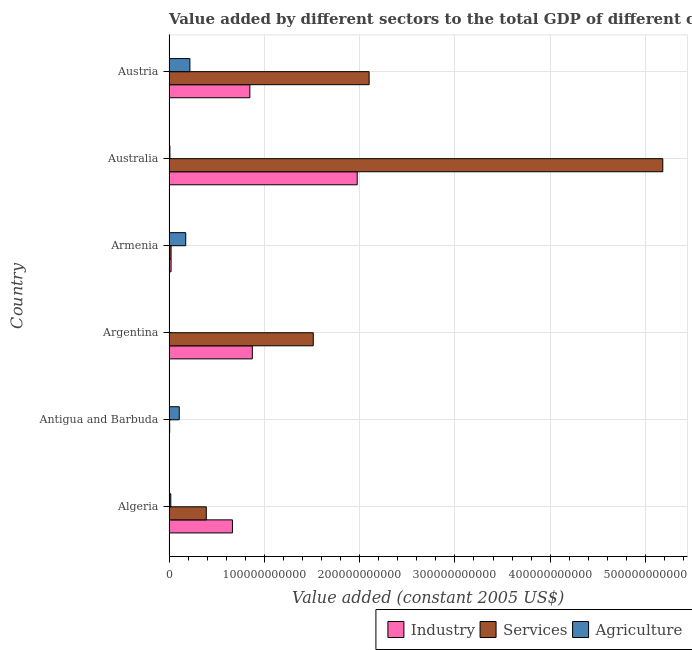Are the number of bars per tick equal to the number of legend labels?
Provide a succinct answer. Yes. What is the label of the 1st group of bars from the top?
Offer a very short reply. Austria. What is the value added by agricultural sector in Austria?
Your answer should be compact. 2.19e+1. Across all countries, what is the maximum value added by industrial sector?
Offer a very short reply. 1.97e+11. Across all countries, what is the minimum value added by industrial sector?
Ensure brevity in your answer.  1.52e+08. In which country was the value added by agricultural sector maximum?
Offer a terse response. Austria. In which country was the value added by services minimum?
Ensure brevity in your answer.  Antigua and Barbuda. What is the total value added by agricultural sector in the graph?
Your answer should be compact. 5.31e+1. What is the difference between the value added by services in Algeria and that in Antigua and Barbuda?
Provide a succinct answer. 3.84e+1. What is the difference between the value added by agricultural sector in Austria and the value added by services in Algeria?
Your response must be concise. -1.72e+1. What is the average value added by services per country?
Keep it short and to the point. 1.54e+11. What is the difference between the value added by industrial sector and value added by agricultural sector in Argentina?
Keep it short and to the point. 8.74e+1. What is the ratio of the value added by industrial sector in Australia to that in Austria?
Give a very brief answer. 2.33. Is the value added by agricultural sector in Antigua and Barbuda less than that in Austria?
Keep it short and to the point. Yes. What is the difference between the highest and the second highest value added by agricultural sector?
Give a very brief answer. 4.37e+09. What is the difference between the highest and the lowest value added by services?
Keep it short and to the point. 5.17e+11. Is the sum of the value added by services in Australia and Austria greater than the maximum value added by agricultural sector across all countries?
Offer a terse response. Yes. What does the 3rd bar from the top in Argentina represents?
Keep it short and to the point. Industry. What does the 1st bar from the bottom in Argentina represents?
Make the answer very short. Industry. Is it the case that in every country, the sum of the value added by industrial sector and value added by services is greater than the value added by agricultural sector?
Your response must be concise. No. How many bars are there?
Give a very brief answer. 18. Are all the bars in the graph horizontal?
Offer a terse response. Yes. What is the difference between two consecutive major ticks on the X-axis?
Give a very brief answer. 1.00e+11. Are the values on the major ticks of X-axis written in scientific E-notation?
Your answer should be compact. No. Does the graph contain any zero values?
Ensure brevity in your answer.  No. How many legend labels are there?
Your response must be concise. 3. How are the legend labels stacked?
Offer a very short reply. Horizontal. What is the title of the graph?
Your answer should be compact. Value added by different sectors to the total GDP of different countries. Does "Agriculture" appear as one of the legend labels in the graph?
Provide a short and direct response. Yes. What is the label or title of the X-axis?
Give a very brief answer. Value added (constant 2005 US$). What is the Value added (constant 2005 US$) of Industry in Algeria?
Your answer should be very brief. 6.66e+1. What is the Value added (constant 2005 US$) in Services in Algeria?
Your response must be concise. 3.91e+1. What is the Value added (constant 2005 US$) in Agriculture in Algeria?
Offer a terse response. 1.89e+09. What is the Value added (constant 2005 US$) in Industry in Antigua and Barbuda?
Keep it short and to the point. 1.52e+08. What is the Value added (constant 2005 US$) in Services in Antigua and Barbuda?
Provide a succinct answer. 7.00e+08. What is the Value added (constant 2005 US$) of Agriculture in Antigua and Barbuda?
Offer a terse response. 1.07e+1. What is the Value added (constant 2005 US$) of Industry in Argentina?
Offer a terse response. 8.74e+1. What is the Value added (constant 2005 US$) of Services in Argentina?
Give a very brief answer. 1.51e+11. What is the Value added (constant 2005 US$) in Agriculture in Argentina?
Offer a terse response. 1.53e+07. What is the Value added (constant 2005 US$) of Industry in Armenia?
Provide a short and direct response. 2.17e+09. What is the Value added (constant 2005 US$) in Services in Armenia?
Give a very brief answer. 2.16e+09. What is the Value added (constant 2005 US$) of Agriculture in Armenia?
Provide a succinct answer. 1.76e+1. What is the Value added (constant 2005 US$) in Industry in Australia?
Keep it short and to the point. 1.97e+11. What is the Value added (constant 2005 US$) of Services in Australia?
Your response must be concise. 5.18e+11. What is the Value added (constant 2005 US$) in Agriculture in Australia?
Offer a very short reply. 9.52e+08. What is the Value added (constant 2005 US$) in Industry in Austria?
Your answer should be compact. 8.48e+1. What is the Value added (constant 2005 US$) in Services in Austria?
Offer a very short reply. 2.10e+11. What is the Value added (constant 2005 US$) of Agriculture in Austria?
Make the answer very short. 2.19e+1. Across all countries, what is the maximum Value added (constant 2005 US$) of Industry?
Make the answer very short. 1.97e+11. Across all countries, what is the maximum Value added (constant 2005 US$) in Services?
Make the answer very short. 5.18e+11. Across all countries, what is the maximum Value added (constant 2005 US$) in Agriculture?
Ensure brevity in your answer.  2.19e+1. Across all countries, what is the minimum Value added (constant 2005 US$) in Industry?
Ensure brevity in your answer.  1.52e+08. Across all countries, what is the minimum Value added (constant 2005 US$) in Services?
Your response must be concise. 7.00e+08. Across all countries, what is the minimum Value added (constant 2005 US$) of Agriculture?
Provide a short and direct response. 1.53e+07. What is the total Value added (constant 2005 US$) of Industry in the graph?
Your response must be concise. 4.39e+11. What is the total Value added (constant 2005 US$) in Services in the graph?
Provide a succinct answer. 9.21e+11. What is the total Value added (constant 2005 US$) in Agriculture in the graph?
Your answer should be very brief. 5.31e+1. What is the difference between the Value added (constant 2005 US$) of Industry in Algeria and that in Antigua and Barbuda?
Make the answer very short. 6.64e+1. What is the difference between the Value added (constant 2005 US$) of Services in Algeria and that in Antigua and Barbuda?
Provide a succinct answer. 3.84e+1. What is the difference between the Value added (constant 2005 US$) of Agriculture in Algeria and that in Antigua and Barbuda?
Ensure brevity in your answer.  -8.86e+09. What is the difference between the Value added (constant 2005 US$) of Industry in Algeria and that in Argentina?
Offer a very short reply. -2.08e+1. What is the difference between the Value added (constant 2005 US$) in Services in Algeria and that in Argentina?
Your answer should be compact. -1.12e+11. What is the difference between the Value added (constant 2005 US$) in Agriculture in Algeria and that in Argentina?
Offer a very short reply. 1.87e+09. What is the difference between the Value added (constant 2005 US$) in Industry in Algeria and that in Armenia?
Ensure brevity in your answer.  6.44e+1. What is the difference between the Value added (constant 2005 US$) of Services in Algeria and that in Armenia?
Offer a terse response. 3.70e+1. What is the difference between the Value added (constant 2005 US$) in Agriculture in Algeria and that in Armenia?
Offer a terse response. -1.57e+1. What is the difference between the Value added (constant 2005 US$) in Industry in Algeria and that in Australia?
Keep it short and to the point. -1.31e+11. What is the difference between the Value added (constant 2005 US$) in Services in Algeria and that in Australia?
Make the answer very short. -4.79e+11. What is the difference between the Value added (constant 2005 US$) in Agriculture in Algeria and that in Australia?
Make the answer very short. 9.36e+08. What is the difference between the Value added (constant 2005 US$) in Industry in Algeria and that in Austria?
Offer a terse response. -1.83e+1. What is the difference between the Value added (constant 2005 US$) in Services in Algeria and that in Austria?
Keep it short and to the point. -1.71e+11. What is the difference between the Value added (constant 2005 US$) of Agriculture in Algeria and that in Austria?
Keep it short and to the point. -2.00e+1. What is the difference between the Value added (constant 2005 US$) of Industry in Antigua and Barbuda and that in Argentina?
Give a very brief answer. -8.73e+1. What is the difference between the Value added (constant 2005 US$) in Services in Antigua and Barbuda and that in Argentina?
Your answer should be compact. -1.51e+11. What is the difference between the Value added (constant 2005 US$) of Agriculture in Antigua and Barbuda and that in Argentina?
Offer a very short reply. 1.07e+1. What is the difference between the Value added (constant 2005 US$) in Industry in Antigua and Barbuda and that in Armenia?
Your response must be concise. -2.02e+09. What is the difference between the Value added (constant 2005 US$) in Services in Antigua and Barbuda and that in Armenia?
Give a very brief answer. -1.46e+09. What is the difference between the Value added (constant 2005 US$) of Agriculture in Antigua and Barbuda and that in Armenia?
Offer a very short reply. -6.81e+09. What is the difference between the Value added (constant 2005 US$) of Industry in Antigua and Barbuda and that in Australia?
Your answer should be compact. -1.97e+11. What is the difference between the Value added (constant 2005 US$) in Services in Antigua and Barbuda and that in Australia?
Your answer should be compact. -5.17e+11. What is the difference between the Value added (constant 2005 US$) of Agriculture in Antigua and Barbuda and that in Australia?
Your response must be concise. 9.80e+09. What is the difference between the Value added (constant 2005 US$) in Industry in Antigua and Barbuda and that in Austria?
Provide a short and direct response. -8.47e+1. What is the difference between the Value added (constant 2005 US$) of Services in Antigua and Barbuda and that in Austria?
Give a very brief answer. -2.09e+11. What is the difference between the Value added (constant 2005 US$) of Agriculture in Antigua and Barbuda and that in Austria?
Offer a terse response. -1.12e+1. What is the difference between the Value added (constant 2005 US$) of Industry in Argentina and that in Armenia?
Provide a short and direct response. 8.52e+1. What is the difference between the Value added (constant 2005 US$) of Services in Argentina and that in Armenia?
Provide a short and direct response. 1.49e+11. What is the difference between the Value added (constant 2005 US$) in Agriculture in Argentina and that in Armenia?
Your response must be concise. -1.75e+1. What is the difference between the Value added (constant 2005 US$) in Industry in Argentina and that in Australia?
Your answer should be compact. -1.10e+11. What is the difference between the Value added (constant 2005 US$) of Services in Argentina and that in Australia?
Make the answer very short. -3.67e+11. What is the difference between the Value added (constant 2005 US$) of Agriculture in Argentina and that in Australia?
Your answer should be compact. -9.36e+08. What is the difference between the Value added (constant 2005 US$) of Industry in Argentina and that in Austria?
Offer a very short reply. 2.59e+09. What is the difference between the Value added (constant 2005 US$) in Services in Argentina and that in Austria?
Offer a very short reply. -5.86e+1. What is the difference between the Value added (constant 2005 US$) of Agriculture in Argentina and that in Austria?
Ensure brevity in your answer.  -2.19e+1. What is the difference between the Value added (constant 2005 US$) in Industry in Armenia and that in Australia?
Make the answer very short. -1.95e+11. What is the difference between the Value added (constant 2005 US$) in Services in Armenia and that in Australia?
Your answer should be very brief. -5.16e+11. What is the difference between the Value added (constant 2005 US$) in Agriculture in Armenia and that in Australia?
Ensure brevity in your answer.  1.66e+1. What is the difference between the Value added (constant 2005 US$) of Industry in Armenia and that in Austria?
Provide a succinct answer. -8.27e+1. What is the difference between the Value added (constant 2005 US$) of Services in Armenia and that in Austria?
Provide a short and direct response. -2.08e+11. What is the difference between the Value added (constant 2005 US$) of Agriculture in Armenia and that in Austria?
Provide a succinct answer. -4.37e+09. What is the difference between the Value added (constant 2005 US$) in Industry in Australia and that in Austria?
Give a very brief answer. 1.13e+11. What is the difference between the Value added (constant 2005 US$) in Services in Australia and that in Austria?
Provide a short and direct response. 3.08e+11. What is the difference between the Value added (constant 2005 US$) in Agriculture in Australia and that in Austria?
Provide a succinct answer. -2.10e+1. What is the difference between the Value added (constant 2005 US$) of Industry in Algeria and the Value added (constant 2005 US$) of Services in Antigua and Barbuda?
Provide a short and direct response. 6.59e+1. What is the difference between the Value added (constant 2005 US$) of Industry in Algeria and the Value added (constant 2005 US$) of Agriculture in Antigua and Barbuda?
Your response must be concise. 5.58e+1. What is the difference between the Value added (constant 2005 US$) in Services in Algeria and the Value added (constant 2005 US$) in Agriculture in Antigua and Barbuda?
Make the answer very short. 2.84e+1. What is the difference between the Value added (constant 2005 US$) of Industry in Algeria and the Value added (constant 2005 US$) of Services in Argentina?
Ensure brevity in your answer.  -8.48e+1. What is the difference between the Value added (constant 2005 US$) of Industry in Algeria and the Value added (constant 2005 US$) of Agriculture in Argentina?
Give a very brief answer. 6.65e+1. What is the difference between the Value added (constant 2005 US$) of Services in Algeria and the Value added (constant 2005 US$) of Agriculture in Argentina?
Your response must be concise. 3.91e+1. What is the difference between the Value added (constant 2005 US$) in Industry in Algeria and the Value added (constant 2005 US$) in Services in Armenia?
Keep it short and to the point. 6.44e+1. What is the difference between the Value added (constant 2005 US$) in Industry in Algeria and the Value added (constant 2005 US$) in Agriculture in Armenia?
Offer a terse response. 4.90e+1. What is the difference between the Value added (constant 2005 US$) of Services in Algeria and the Value added (constant 2005 US$) of Agriculture in Armenia?
Give a very brief answer. 2.16e+1. What is the difference between the Value added (constant 2005 US$) in Industry in Algeria and the Value added (constant 2005 US$) in Services in Australia?
Keep it short and to the point. -4.52e+11. What is the difference between the Value added (constant 2005 US$) of Industry in Algeria and the Value added (constant 2005 US$) of Agriculture in Australia?
Offer a terse response. 6.56e+1. What is the difference between the Value added (constant 2005 US$) in Services in Algeria and the Value added (constant 2005 US$) in Agriculture in Australia?
Your answer should be compact. 3.82e+1. What is the difference between the Value added (constant 2005 US$) in Industry in Algeria and the Value added (constant 2005 US$) in Services in Austria?
Your answer should be very brief. -1.43e+11. What is the difference between the Value added (constant 2005 US$) in Industry in Algeria and the Value added (constant 2005 US$) in Agriculture in Austria?
Your answer should be very brief. 4.46e+1. What is the difference between the Value added (constant 2005 US$) in Services in Algeria and the Value added (constant 2005 US$) in Agriculture in Austria?
Your answer should be very brief. 1.72e+1. What is the difference between the Value added (constant 2005 US$) in Industry in Antigua and Barbuda and the Value added (constant 2005 US$) in Services in Argentina?
Make the answer very short. -1.51e+11. What is the difference between the Value added (constant 2005 US$) in Industry in Antigua and Barbuda and the Value added (constant 2005 US$) in Agriculture in Argentina?
Ensure brevity in your answer.  1.37e+08. What is the difference between the Value added (constant 2005 US$) in Services in Antigua and Barbuda and the Value added (constant 2005 US$) in Agriculture in Argentina?
Your answer should be compact. 6.85e+08. What is the difference between the Value added (constant 2005 US$) in Industry in Antigua and Barbuda and the Value added (constant 2005 US$) in Services in Armenia?
Your answer should be compact. -2.01e+09. What is the difference between the Value added (constant 2005 US$) in Industry in Antigua and Barbuda and the Value added (constant 2005 US$) in Agriculture in Armenia?
Offer a very short reply. -1.74e+1. What is the difference between the Value added (constant 2005 US$) of Services in Antigua and Barbuda and the Value added (constant 2005 US$) of Agriculture in Armenia?
Your response must be concise. -1.69e+1. What is the difference between the Value added (constant 2005 US$) of Industry in Antigua and Barbuda and the Value added (constant 2005 US$) of Services in Australia?
Your response must be concise. -5.18e+11. What is the difference between the Value added (constant 2005 US$) of Industry in Antigua and Barbuda and the Value added (constant 2005 US$) of Agriculture in Australia?
Keep it short and to the point. -8.00e+08. What is the difference between the Value added (constant 2005 US$) in Services in Antigua and Barbuda and the Value added (constant 2005 US$) in Agriculture in Australia?
Give a very brief answer. -2.51e+08. What is the difference between the Value added (constant 2005 US$) in Industry in Antigua and Barbuda and the Value added (constant 2005 US$) in Services in Austria?
Keep it short and to the point. -2.10e+11. What is the difference between the Value added (constant 2005 US$) in Industry in Antigua and Barbuda and the Value added (constant 2005 US$) in Agriculture in Austria?
Give a very brief answer. -2.18e+1. What is the difference between the Value added (constant 2005 US$) in Services in Antigua and Barbuda and the Value added (constant 2005 US$) in Agriculture in Austria?
Ensure brevity in your answer.  -2.12e+1. What is the difference between the Value added (constant 2005 US$) of Industry in Argentina and the Value added (constant 2005 US$) of Services in Armenia?
Keep it short and to the point. 8.52e+1. What is the difference between the Value added (constant 2005 US$) of Industry in Argentina and the Value added (constant 2005 US$) of Agriculture in Armenia?
Offer a very short reply. 6.99e+1. What is the difference between the Value added (constant 2005 US$) of Services in Argentina and the Value added (constant 2005 US$) of Agriculture in Armenia?
Offer a very short reply. 1.34e+11. What is the difference between the Value added (constant 2005 US$) in Industry in Argentina and the Value added (constant 2005 US$) in Services in Australia?
Offer a terse response. -4.31e+11. What is the difference between the Value added (constant 2005 US$) of Industry in Argentina and the Value added (constant 2005 US$) of Agriculture in Australia?
Your response must be concise. 8.65e+1. What is the difference between the Value added (constant 2005 US$) of Services in Argentina and the Value added (constant 2005 US$) of Agriculture in Australia?
Your answer should be compact. 1.50e+11. What is the difference between the Value added (constant 2005 US$) of Industry in Argentina and the Value added (constant 2005 US$) of Services in Austria?
Give a very brief answer. -1.23e+11. What is the difference between the Value added (constant 2005 US$) of Industry in Argentina and the Value added (constant 2005 US$) of Agriculture in Austria?
Make the answer very short. 6.55e+1. What is the difference between the Value added (constant 2005 US$) of Services in Argentina and the Value added (constant 2005 US$) of Agriculture in Austria?
Provide a short and direct response. 1.29e+11. What is the difference between the Value added (constant 2005 US$) in Industry in Armenia and the Value added (constant 2005 US$) in Services in Australia?
Provide a succinct answer. -5.16e+11. What is the difference between the Value added (constant 2005 US$) of Industry in Armenia and the Value added (constant 2005 US$) of Agriculture in Australia?
Ensure brevity in your answer.  1.22e+09. What is the difference between the Value added (constant 2005 US$) in Services in Armenia and the Value added (constant 2005 US$) in Agriculture in Australia?
Offer a very short reply. 1.21e+09. What is the difference between the Value added (constant 2005 US$) of Industry in Armenia and the Value added (constant 2005 US$) of Services in Austria?
Give a very brief answer. -2.08e+11. What is the difference between the Value added (constant 2005 US$) of Industry in Armenia and the Value added (constant 2005 US$) of Agriculture in Austria?
Ensure brevity in your answer.  -1.98e+1. What is the difference between the Value added (constant 2005 US$) of Services in Armenia and the Value added (constant 2005 US$) of Agriculture in Austria?
Make the answer very short. -1.98e+1. What is the difference between the Value added (constant 2005 US$) of Industry in Australia and the Value added (constant 2005 US$) of Services in Austria?
Provide a succinct answer. -1.25e+1. What is the difference between the Value added (constant 2005 US$) of Industry in Australia and the Value added (constant 2005 US$) of Agriculture in Austria?
Ensure brevity in your answer.  1.76e+11. What is the difference between the Value added (constant 2005 US$) of Services in Australia and the Value added (constant 2005 US$) of Agriculture in Austria?
Keep it short and to the point. 4.96e+11. What is the average Value added (constant 2005 US$) of Industry per country?
Offer a terse response. 7.31e+1. What is the average Value added (constant 2005 US$) of Services per country?
Your response must be concise. 1.54e+11. What is the average Value added (constant 2005 US$) of Agriculture per country?
Your response must be concise. 8.85e+09. What is the difference between the Value added (constant 2005 US$) in Industry and Value added (constant 2005 US$) in Services in Algeria?
Make the answer very short. 2.74e+1. What is the difference between the Value added (constant 2005 US$) of Industry and Value added (constant 2005 US$) of Agriculture in Algeria?
Offer a terse response. 6.47e+1. What is the difference between the Value added (constant 2005 US$) in Services and Value added (constant 2005 US$) in Agriculture in Algeria?
Your answer should be compact. 3.72e+1. What is the difference between the Value added (constant 2005 US$) of Industry and Value added (constant 2005 US$) of Services in Antigua and Barbuda?
Provide a short and direct response. -5.48e+08. What is the difference between the Value added (constant 2005 US$) of Industry and Value added (constant 2005 US$) of Agriculture in Antigua and Barbuda?
Make the answer very short. -1.06e+1. What is the difference between the Value added (constant 2005 US$) in Services and Value added (constant 2005 US$) in Agriculture in Antigua and Barbuda?
Keep it short and to the point. -1.00e+1. What is the difference between the Value added (constant 2005 US$) in Industry and Value added (constant 2005 US$) in Services in Argentina?
Make the answer very short. -6.40e+1. What is the difference between the Value added (constant 2005 US$) in Industry and Value added (constant 2005 US$) in Agriculture in Argentina?
Provide a succinct answer. 8.74e+1. What is the difference between the Value added (constant 2005 US$) in Services and Value added (constant 2005 US$) in Agriculture in Argentina?
Your answer should be very brief. 1.51e+11. What is the difference between the Value added (constant 2005 US$) in Industry and Value added (constant 2005 US$) in Services in Armenia?
Give a very brief answer. 5.08e+06. What is the difference between the Value added (constant 2005 US$) in Industry and Value added (constant 2005 US$) in Agriculture in Armenia?
Give a very brief answer. -1.54e+1. What is the difference between the Value added (constant 2005 US$) of Services and Value added (constant 2005 US$) of Agriculture in Armenia?
Offer a very short reply. -1.54e+1. What is the difference between the Value added (constant 2005 US$) in Industry and Value added (constant 2005 US$) in Services in Australia?
Offer a terse response. -3.21e+11. What is the difference between the Value added (constant 2005 US$) of Industry and Value added (constant 2005 US$) of Agriculture in Australia?
Give a very brief answer. 1.97e+11. What is the difference between the Value added (constant 2005 US$) in Services and Value added (constant 2005 US$) in Agriculture in Australia?
Keep it short and to the point. 5.17e+11. What is the difference between the Value added (constant 2005 US$) in Industry and Value added (constant 2005 US$) in Services in Austria?
Offer a very short reply. -1.25e+11. What is the difference between the Value added (constant 2005 US$) of Industry and Value added (constant 2005 US$) of Agriculture in Austria?
Give a very brief answer. 6.29e+1. What is the difference between the Value added (constant 2005 US$) in Services and Value added (constant 2005 US$) in Agriculture in Austria?
Make the answer very short. 1.88e+11. What is the ratio of the Value added (constant 2005 US$) in Industry in Algeria to that in Antigua and Barbuda?
Offer a very short reply. 438.16. What is the ratio of the Value added (constant 2005 US$) of Services in Algeria to that in Antigua and Barbuda?
Offer a very short reply. 55.88. What is the ratio of the Value added (constant 2005 US$) in Agriculture in Algeria to that in Antigua and Barbuda?
Give a very brief answer. 0.18. What is the ratio of the Value added (constant 2005 US$) of Industry in Algeria to that in Argentina?
Give a very brief answer. 0.76. What is the ratio of the Value added (constant 2005 US$) in Services in Algeria to that in Argentina?
Give a very brief answer. 0.26. What is the ratio of the Value added (constant 2005 US$) in Agriculture in Algeria to that in Argentina?
Your answer should be compact. 123.27. What is the ratio of the Value added (constant 2005 US$) of Industry in Algeria to that in Armenia?
Keep it short and to the point. 30.68. What is the ratio of the Value added (constant 2005 US$) of Services in Algeria to that in Armenia?
Offer a very short reply. 18.07. What is the ratio of the Value added (constant 2005 US$) in Agriculture in Algeria to that in Armenia?
Ensure brevity in your answer.  0.11. What is the ratio of the Value added (constant 2005 US$) in Industry in Algeria to that in Australia?
Your answer should be very brief. 0.34. What is the ratio of the Value added (constant 2005 US$) in Services in Algeria to that in Australia?
Offer a very short reply. 0.08. What is the ratio of the Value added (constant 2005 US$) in Agriculture in Algeria to that in Australia?
Offer a very short reply. 1.98. What is the ratio of the Value added (constant 2005 US$) of Industry in Algeria to that in Austria?
Give a very brief answer. 0.78. What is the ratio of the Value added (constant 2005 US$) in Services in Algeria to that in Austria?
Keep it short and to the point. 0.19. What is the ratio of the Value added (constant 2005 US$) in Agriculture in Algeria to that in Austria?
Give a very brief answer. 0.09. What is the ratio of the Value added (constant 2005 US$) in Industry in Antigua and Barbuda to that in Argentina?
Provide a succinct answer. 0. What is the ratio of the Value added (constant 2005 US$) of Services in Antigua and Barbuda to that in Argentina?
Offer a terse response. 0. What is the ratio of the Value added (constant 2005 US$) in Agriculture in Antigua and Barbuda to that in Argentina?
Your answer should be very brief. 701.84. What is the ratio of the Value added (constant 2005 US$) in Industry in Antigua and Barbuda to that in Armenia?
Your answer should be compact. 0.07. What is the ratio of the Value added (constant 2005 US$) of Services in Antigua and Barbuda to that in Armenia?
Ensure brevity in your answer.  0.32. What is the ratio of the Value added (constant 2005 US$) of Agriculture in Antigua and Barbuda to that in Armenia?
Give a very brief answer. 0.61. What is the ratio of the Value added (constant 2005 US$) in Industry in Antigua and Barbuda to that in Australia?
Your answer should be very brief. 0. What is the ratio of the Value added (constant 2005 US$) in Services in Antigua and Barbuda to that in Australia?
Make the answer very short. 0. What is the ratio of the Value added (constant 2005 US$) in Agriculture in Antigua and Barbuda to that in Australia?
Your answer should be very brief. 11.29. What is the ratio of the Value added (constant 2005 US$) of Industry in Antigua and Barbuda to that in Austria?
Offer a very short reply. 0. What is the ratio of the Value added (constant 2005 US$) in Services in Antigua and Barbuda to that in Austria?
Your answer should be compact. 0. What is the ratio of the Value added (constant 2005 US$) in Agriculture in Antigua and Barbuda to that in Austria?
Ensure brevity in your answer.  0.49. What is the ratio of the Value added (constant 2005 US$) of Industry in Argentina to that in Armenia?
Your answer should be compact. 40.29. What is the ratio of the Value added (constant 2005 US$) of Services in Argentina to that in Armenia?
Keep it short and to the point. 69.93. What is the ratio of the Value added (constant 2005 US$) in Agriculture in Argentina to that in Armenia?
Your answer should be very brief. 0. What is the ratio of the Value added (constant 2005 US$) in Industry in Argentina to that in Australia?
Give a very brief answer. 0.44. What is the ratio of the Value added (constant 2005 US$) in Services in Argentina to that in Australia?
Provide a succinct answer. 0.29. What is the ratio of the Value added (constant 2005 US$) in Agriculture in Argentina to that in Australia?
Provide a succinct answer. 0.02. What is the ratio of the Value added (constant 2005 US$) in Industry in Argentina to that in Austria?
Your answer should be very brief. 1.03. What is the ratio of the Value added (constant 2005 US$) of Services in Argentina to that in Austria?
Your answer should be compact. 0.72. What is the ratio of the Value added (constant 2005 US$) in Agriculture in Argentina to that in Austria?
Make the answer very short. 0. What is the ratio of the Value added (constant 2005 US$) in Industry in Armenia to that in Australia?
Make the answer very short. 0.01. What is the ratio of the Value added (constant 2005 US$) of Services in Armenia to that in Australia?
Provide a succinct answer. 0. What is the ratio of the Value added (constant 2005 US$) in Agriculture in Armenia to that in Australia?
Offer a terse response. 18.45. What is the ratio of the Value added (constant 2005 US$) in Industry in Armenia to that in Austria?
Provide a succinct answer. 0.03. What is the ratio of the Value added (constant 2005 US$) of Services in Armenia to that in Austria?
Offer a very short reply. 0.01. What is the ratio of the Value added (constant 2005 US$) of Agriculture in Armenia to that in Austria?
Your response must be concise. 0.8. What is the ratio of the Value added (constant 2005 US$) in Industry in Australia to that in Austria?
Offer a very short reply. 2.33. What is the ratio of the Value added (constant 2005 US$) of Services in Australia to that in Austria?
Ensure brevity in your answer.  2.47. What is the ratio of the Value added (constant 2005 US$) of Agriculture in Australia to that in Austria?
Offer a terse response. 0.04. What is the difference between the highest and the second highest Value added (constant 2005 US$) in Industry?
Offer a terse response. 1.10e+11. What is the difference between the highest and the second highest Value added (constant 2005 US$) of Services?
Make the answer very short. 3.08e+11. What is the difference between the highest and the second highest Value added (constant 2005 US$) in Agriculture?
Keep it short and to the point. 4.37e+09. What is the difference between the highest and the lowest Value added (constant 2005 US$) in Industry?
Provide a short and direct response. 1.97e+11. What is the difference between the highest and the lowest Value added (constant 2005 US$) in Services?
Give a very brief answer. 5.17e+11. What is the difference between the highest and the lowest Value added (constant 2005 US$) in Agriculture?
Your response must be concise. 2.19e+1. 